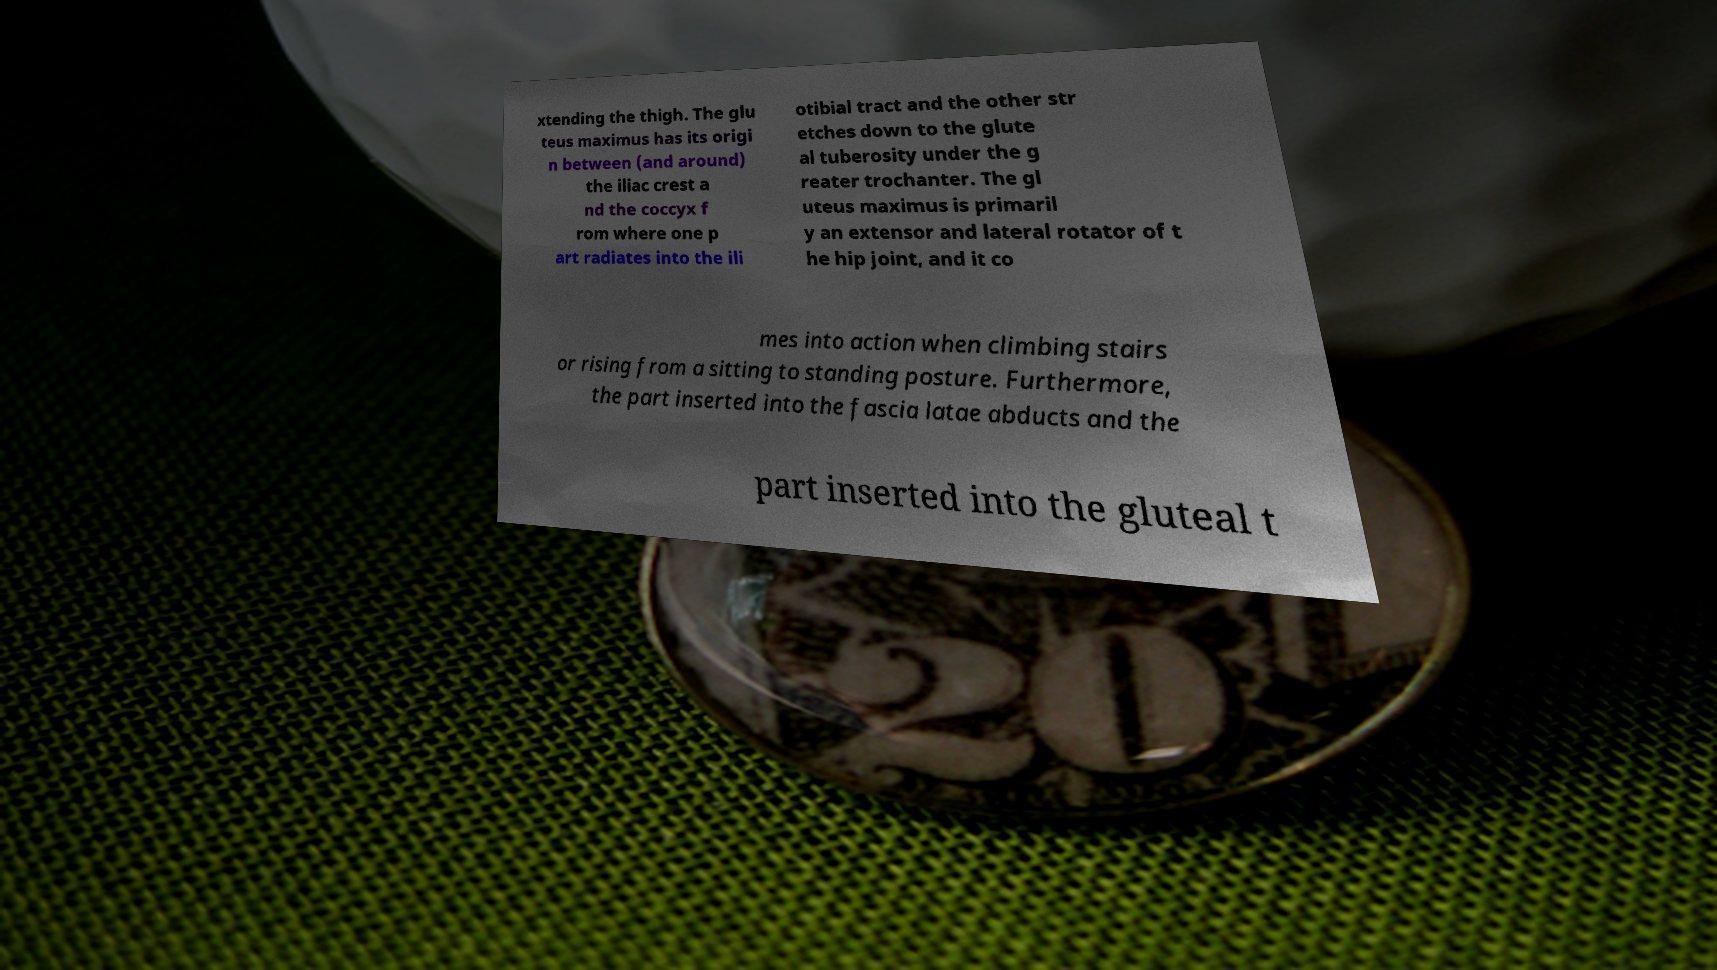Could you assist in decoding the text presented in this image and type it out clearly? xtending the thigh. The glu teus maximus has its origi n between (and around) the iliac crest a nd the coccyx f rom where one p art radiates into the ili otibial tract and the other str etches down to the glute al tuberosity under the g reater trochanter. The gl uteus maximus is primaril y an extensor and lateral rotator of t he hip joint, and it co mes into action when climbing stairs or rising from a sitting to standing posture. Furthermore, the part inserted into the fascia latae abducts and the part inserted into the gluteal t 